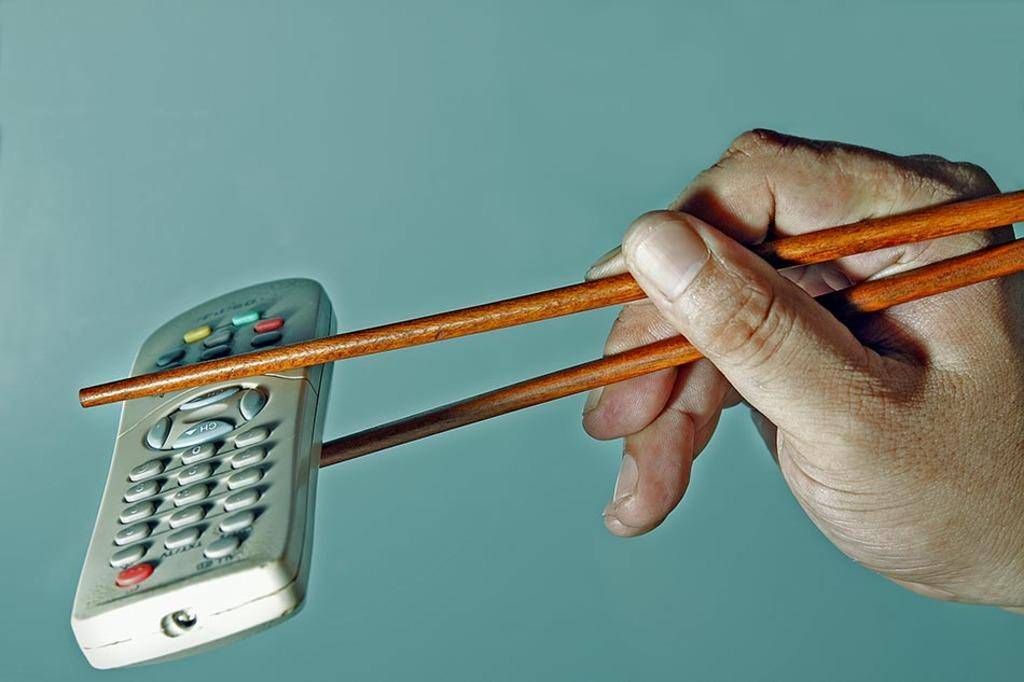What is being held by the hand in the image? The hand is holding chopsticks. What are the chopsticks holding? The chopsticks are holding a remote controller. What can be seen in the background of the image? There is a blue color wall in the background of the image. What type of voyage is the hand embarking on with the remote controller? There is no voyage or sailing activity depicted in the image; it simply shows a hand holding chopsticks that are holding a remote controller. Are there any police officers present in the image? There is no mention or indication of any police officers in the image. 